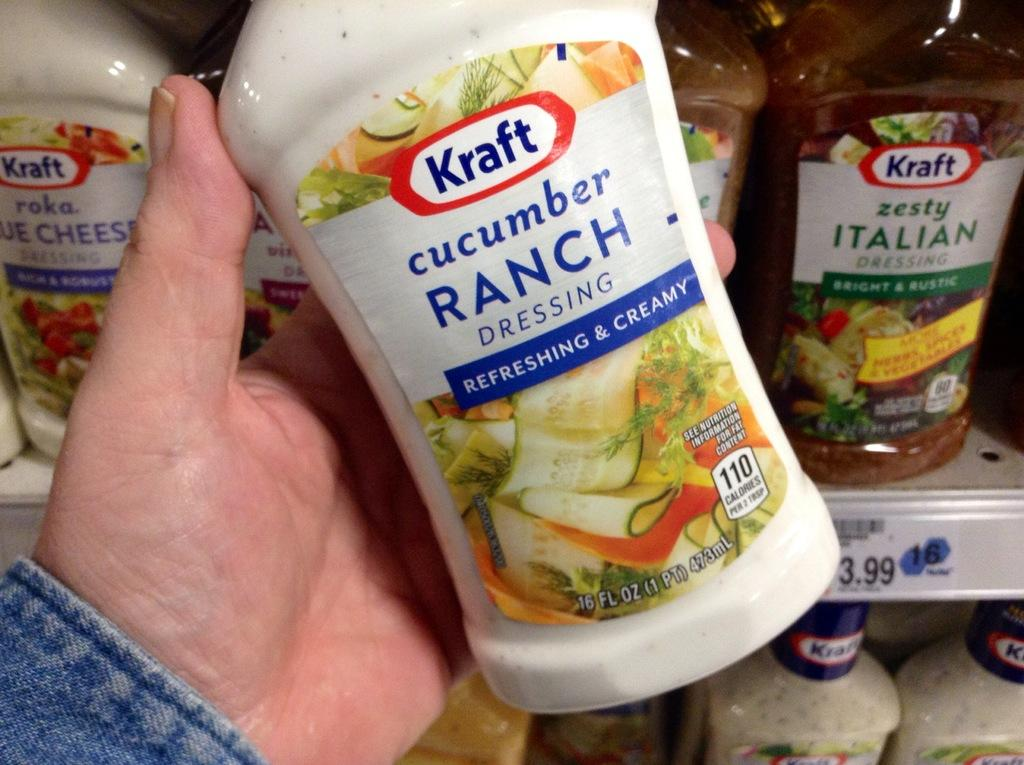Where was the image taken? The image is taken indoors. What is the person in the image holding? The person is holding a cream bottle in their hands. What can be seen in the background of the image? There are many bottles on the shelves in the background. What story is the person telling in the image? There is no indication in the image that the person is telling a story. What type of flooring is visible in the image? The image does not show the floor, so it cannot be determined what type of flooring is visible. 